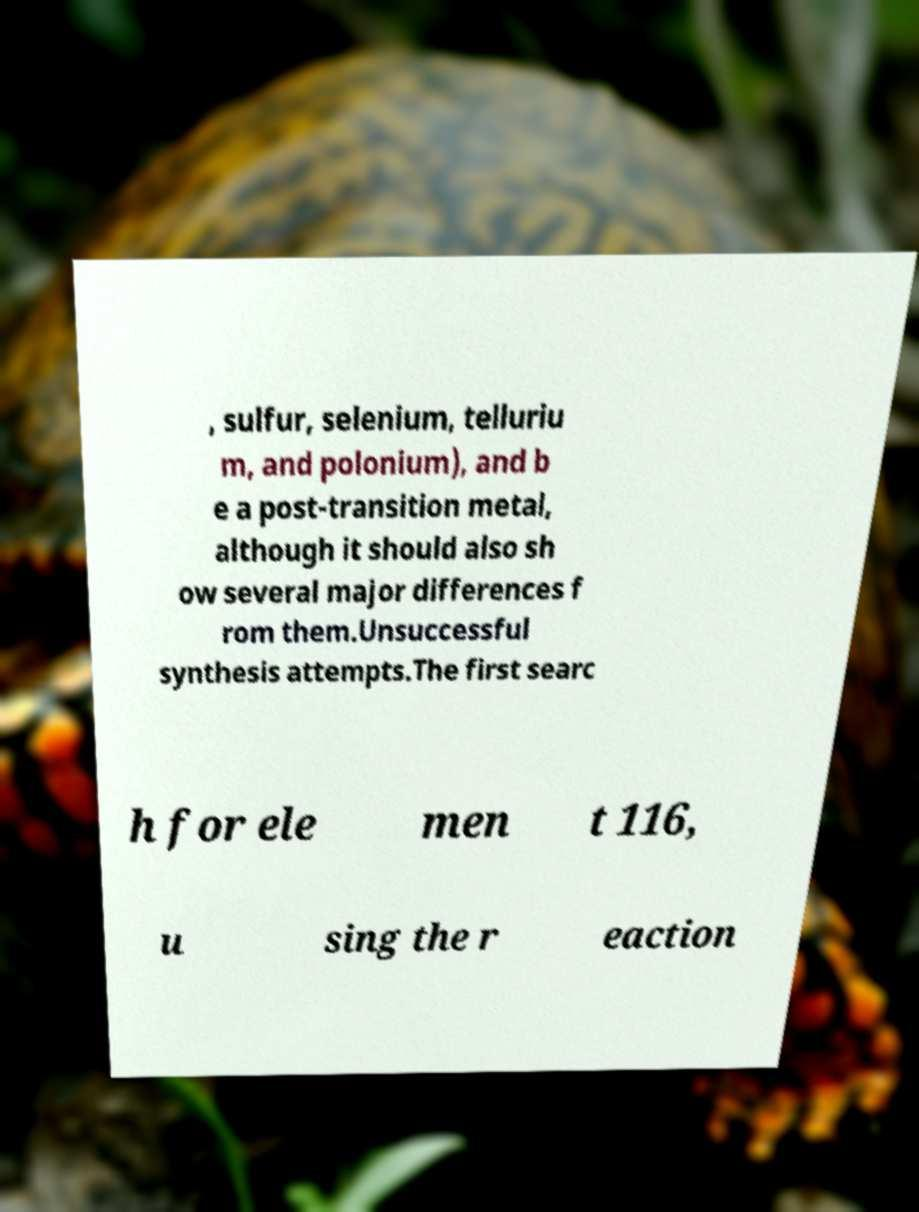Please identify and transcribe the text found in this image. , sulfur, selenium, telluriu m, and polonium), and b e a post-transition metal, although it should also sh ow several major differences f rom them.Unsuccessful synthesis attempts.The first searc h for ele men t 116, u sing the r eaction 